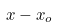<formula> <loc_0><loc_0><loc_500><loc_500>x - x _ { o }</formula> 